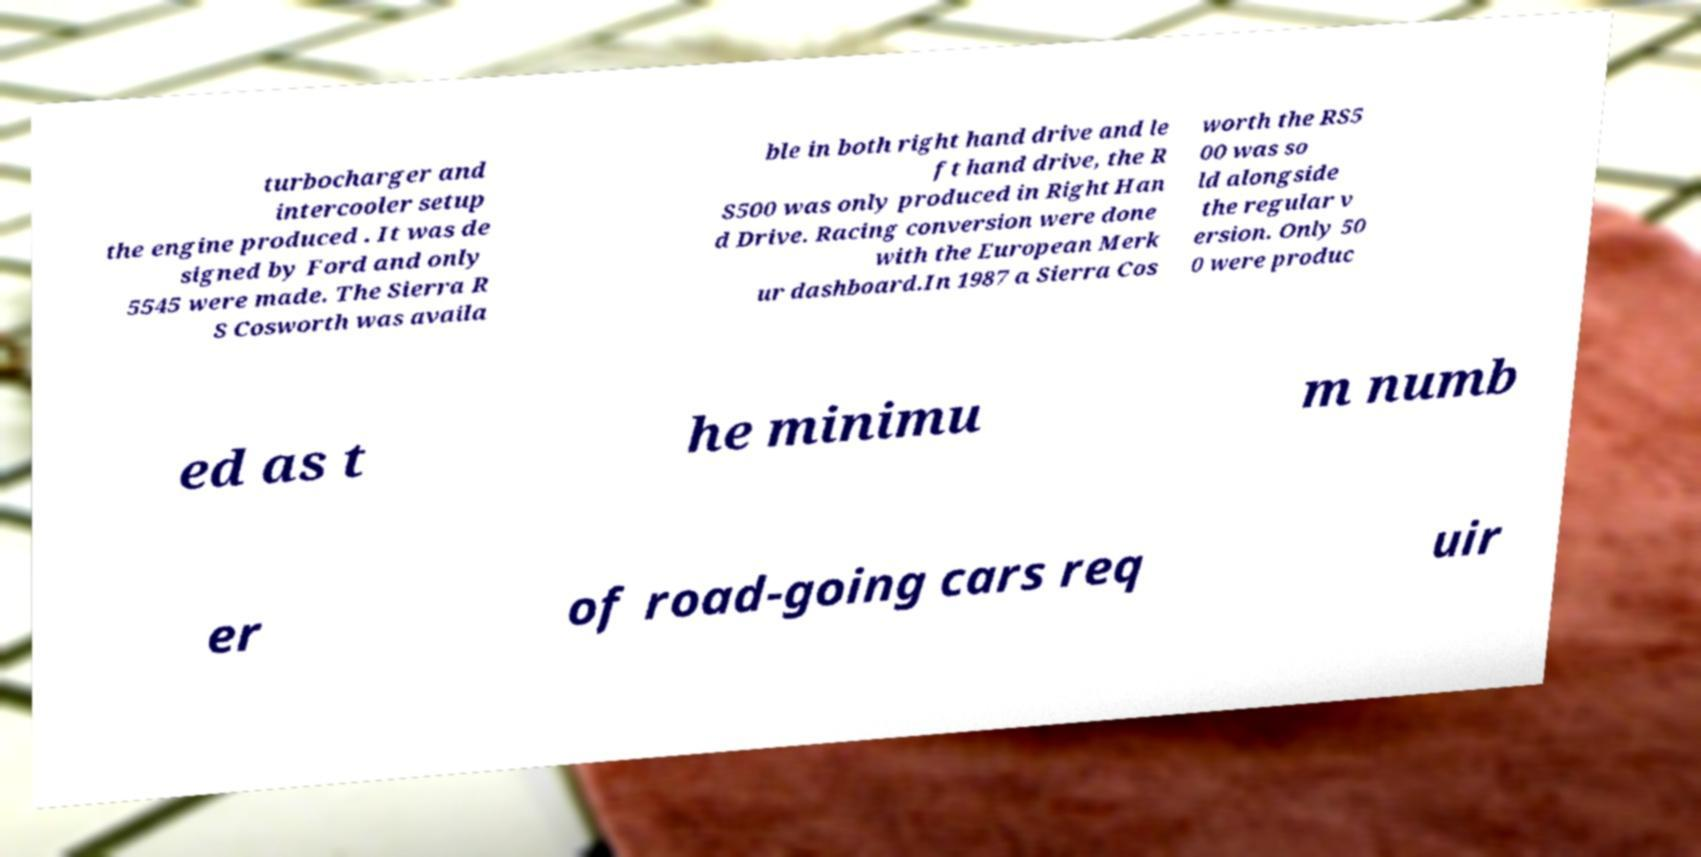Could you assist in decoding the text presented in this image and type it out clearly? turbocharger and intercooler setup the engine produced . It was de signed by Ford and only 5545 were made. The Sierra R S Cosworth was availa ble in both right hand drive and le ft hand drive, the R S500 was only produced in Right Han d Drive. Racing conversion were done with the European Merk ur dashboard.In 1987 a Sierra Cos worth the RS5 00 was so ld alongside the regular v ersion. Only 50 0 were produc ed as t he minimu m numb er of road-going cars req uir 